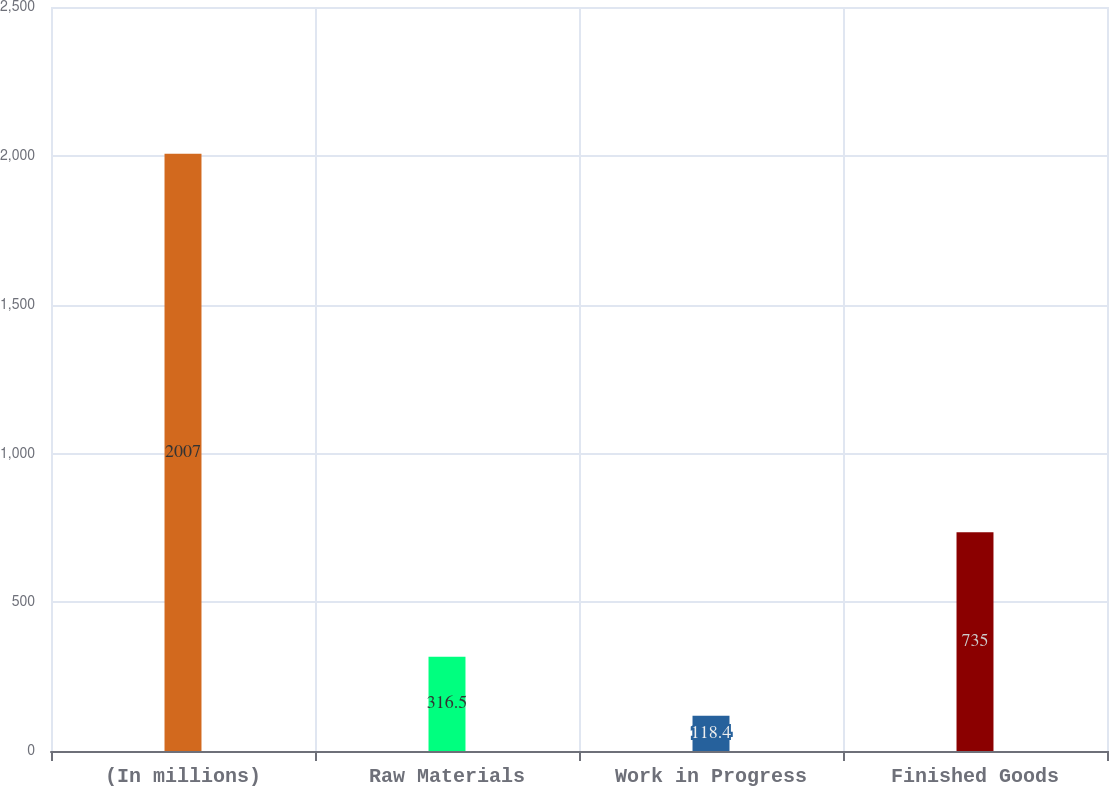Convert chart. <chart><loc_0><loc_0><loc_500><loc_500><bar_chart><fcel>(In millions)<fcel>Raw Materials<fcel>Work in Progress<fcel>Finished Goods<nl><fcel>2007<fcel>316.5<fcel>118.4<fcel>735<nl></chart> 